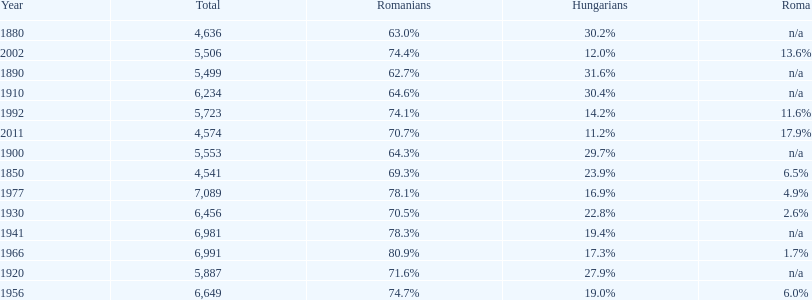In how many cases did the entire population amount to 6,000 or above? 6. 